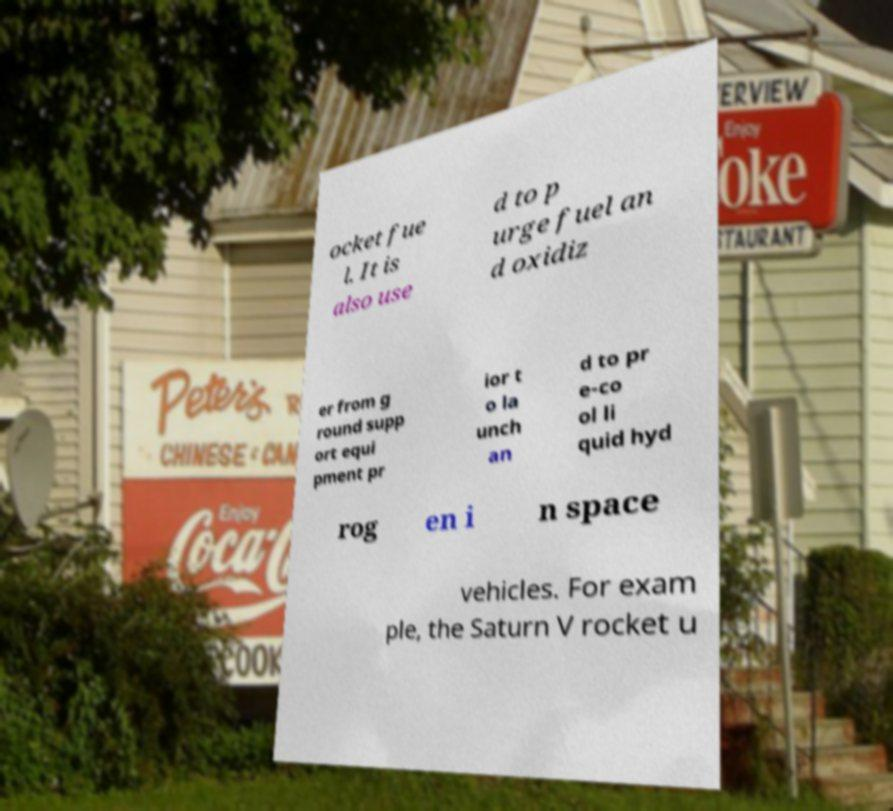Can you accurately transcribe the text from the provided image for me? ocket fue l. It is also use d to p urge fuel an d oxidiz er from g round supp ort equi pment pr ior t o la unch an d to pr e-co ol li quid hyd rog en i n space vehicles. For exam ple, the Saturn V rocket u 